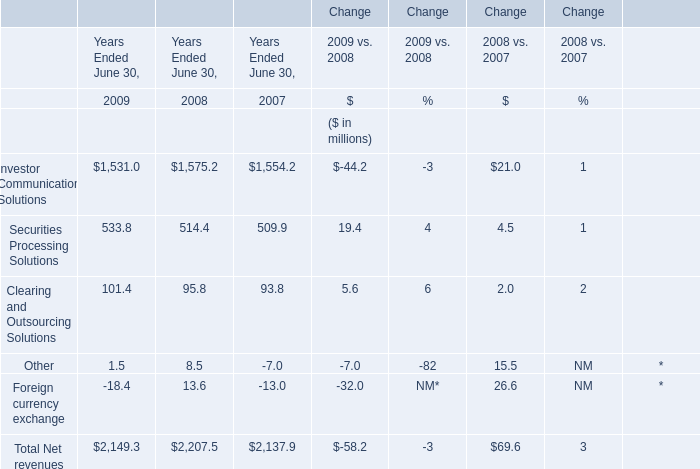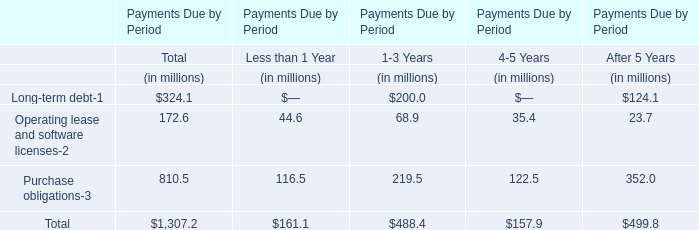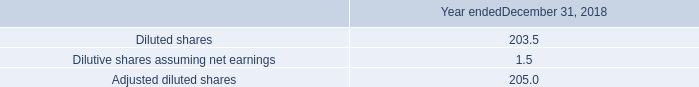In what year is Foreign currency exchange greater than 0? 
Answer: 2008. 